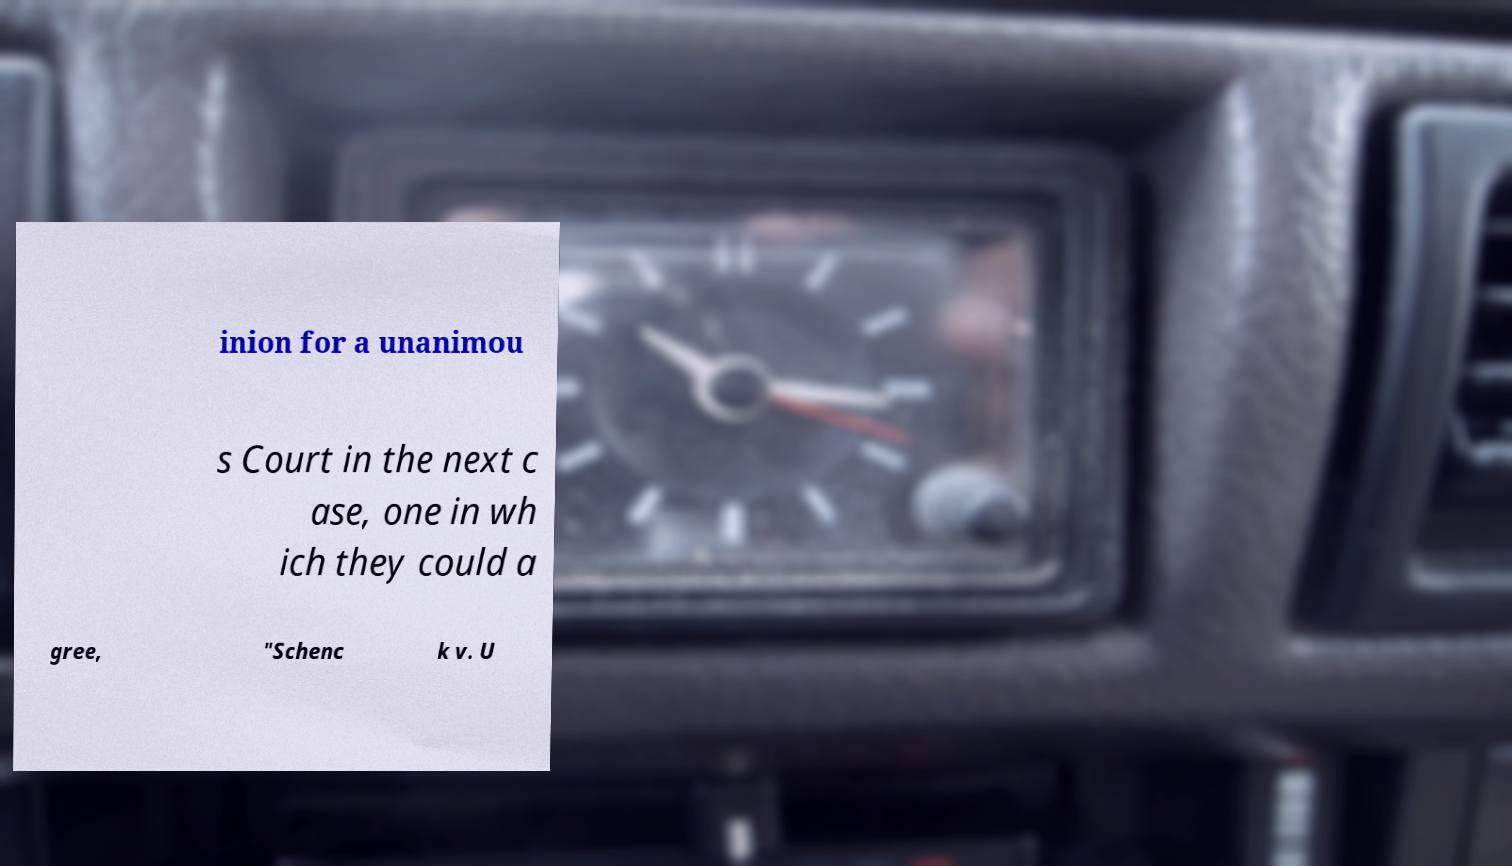Could you assist in decoding the text presented in this image and type it out clearly? inion for a unanimou s Court in the next c ase, one in wh ich they could a gree, "Schenc k v. U 